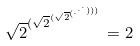<formula> <loc_0><loc_0><loc_500><loc_500>\sqrt { 2 } ^ { ( \sqrt { 2 } ^ { ( \sqrt { 2 } ^ { ( \cdot ^ { \cdot ^ { \cdot } ) ) ) } } } } = 2</formula> 